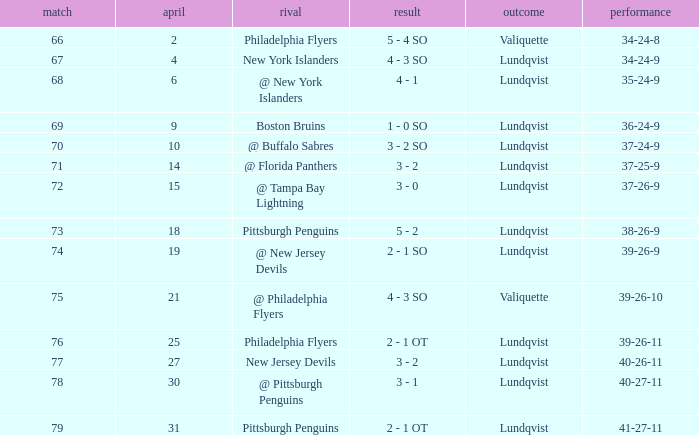Parse the table in full. {'header': ['match', 'april', 'rival', 'result', 'outcome', 'performance'], 'rows': [['66', '2', 'Philadelphia Flyers', '5 - 4 SO', 'Valiquette', '34-24-8'], ['67', '4', 'New York Islanders', '4 - 3 SO', 'Lundqvist', '34-24-9'], ['68', '6', '@ New York Islanders', '4 - 1', 'Lundqvist', '35-24-9'], ['69', '9', 'Boston Bruins', '1 - 0 SO', 'Lundqvist', '36-24-9'], ['70', '10', '@ Buffalo Sabres', '3 - 2 SO', 'Lundqvist', '37-24-9'], ['71', '14', '@ Florida Panthers', '3 - 2', 'Lundqvist', '37-25-9'], ['72', '15', '@ Tampa Bay Lightning', '3 - 0', 'Lundqvist', '37-26-9'], ['73', '18', 'Pittsburgh Penguins', '5 - 2', 'Lundqvist', '38-26-9'], ['74', '19', '@ New Jersey Devils', '2 - 1 SO', 'Lundqvist', '39-26-9'], ['75', '21', '@ Philadelphia Flyers', '4 - 3 SO', 'Valiquette', '39-26-10'], ['76', '25', 'Philadelphia Flyers', '2 - 1 OT', 'Lundqvist', '39-26-11'], ['77', '27', 'New Jersey Devils', '3 - 2', 'Lundqvist', '40-26-11'], ['78', '30', '@ Pittsburgh Penguins', '3 - 1', 'Lundqvist', '40-27-11'], ['79', '31', 'Pittsburgh Penguins', '2 - 1 OT', 'Lundqvist', '41-27-11']]} Which opponent's march was 31? Pittsburgh Penguins. 